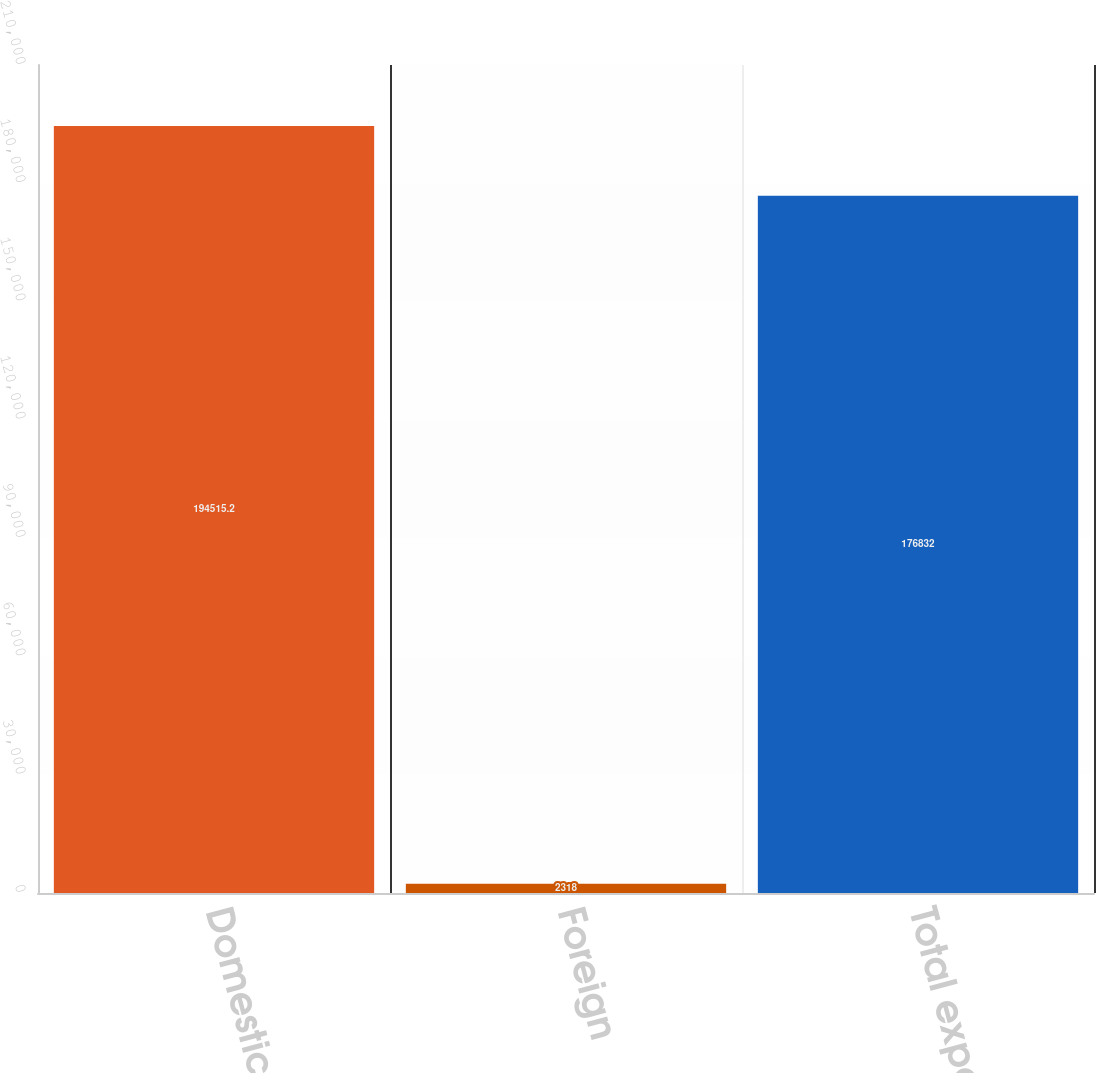Convert chart to OTSL. <chart><loc_0><loc_0><loc_500><loc_500><bar_chart><fcel>Domestic<fcel>Foreign<fcel>Total expense<nl><fcel>194515<fcel>2318<fcel>176832<nl></chart> 